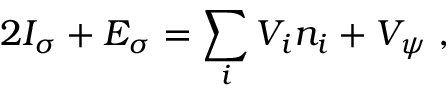<formula> <loc_0><loc_0><loc_500><loc_500>2 I _ { \sigma } + E _ { \sigma } = \sum _ { i } V _ { i } n _ { i } + V _ { \psi } \, ,</formula> 